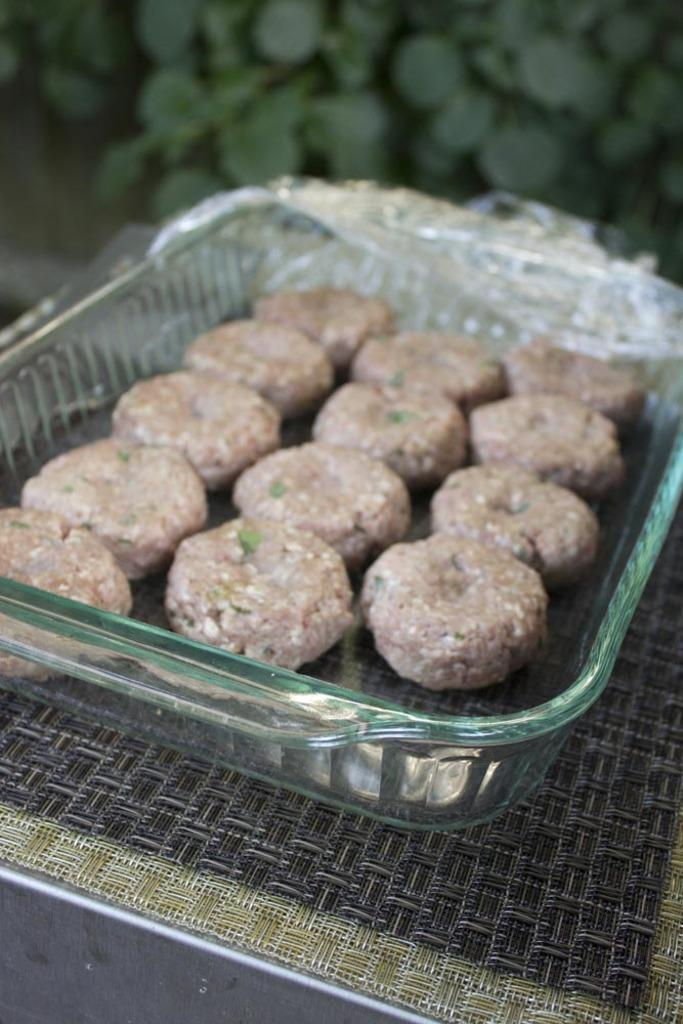What is placed in the bowl in the image? There is an eatable item placed in a bowl. Where is the bowl located? The bowl is kept on a carpet. What type of seed can be seen growing on the carpet in the image? There is no seed or plant growth visible on the carpet in the image. 